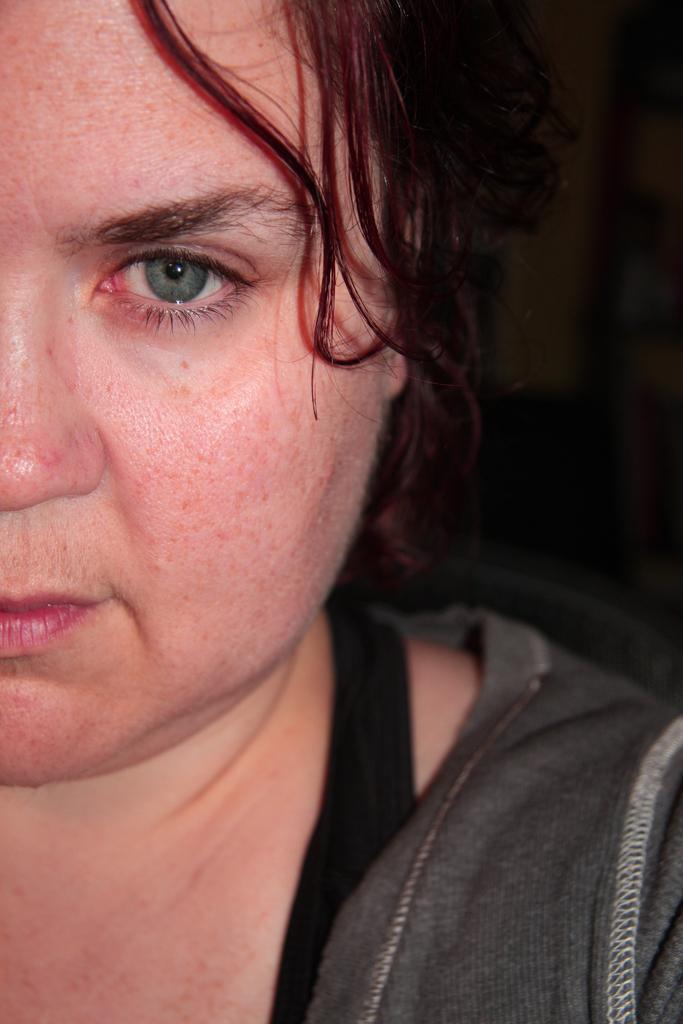Describe this image in one or two sentences. In this image I can see a woman and I can see she is wearing grey colour dress. I can see this image is blurry from background. 